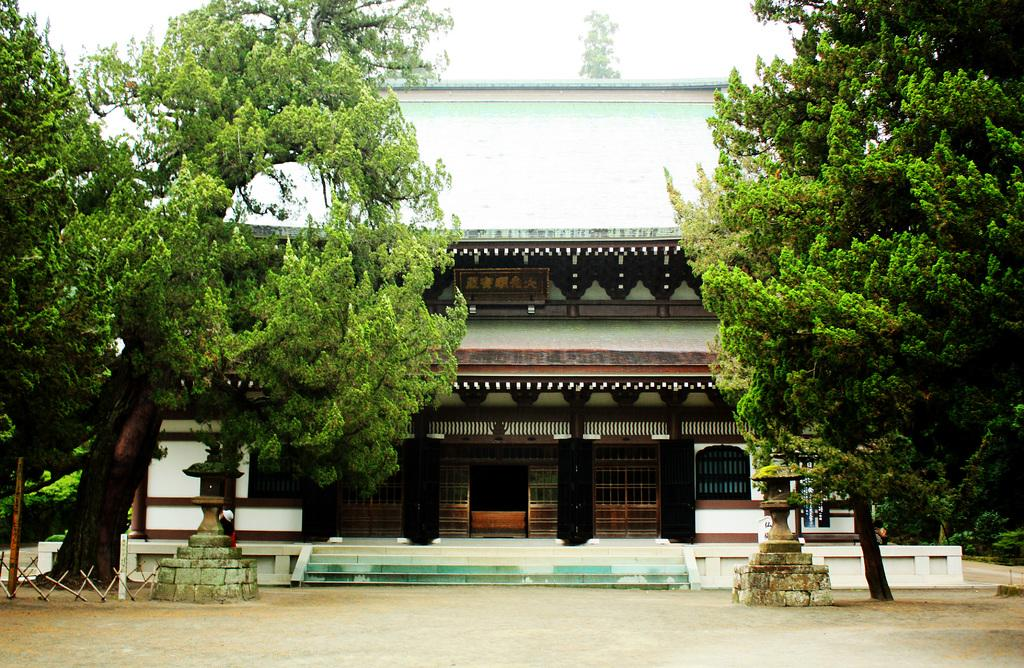What type of structure is present in the image? There is a building in the image. What other elements can be seen in the image? There are trees and pedestals in front of the building. What is visible in the background of the image? The sky is visible in the background of the image. How many jellyfish can be seen swimming in the sky in the image? There are no jellyfish present in the image, and the sky is not depicted as a body of water where jellyfish might swim. 